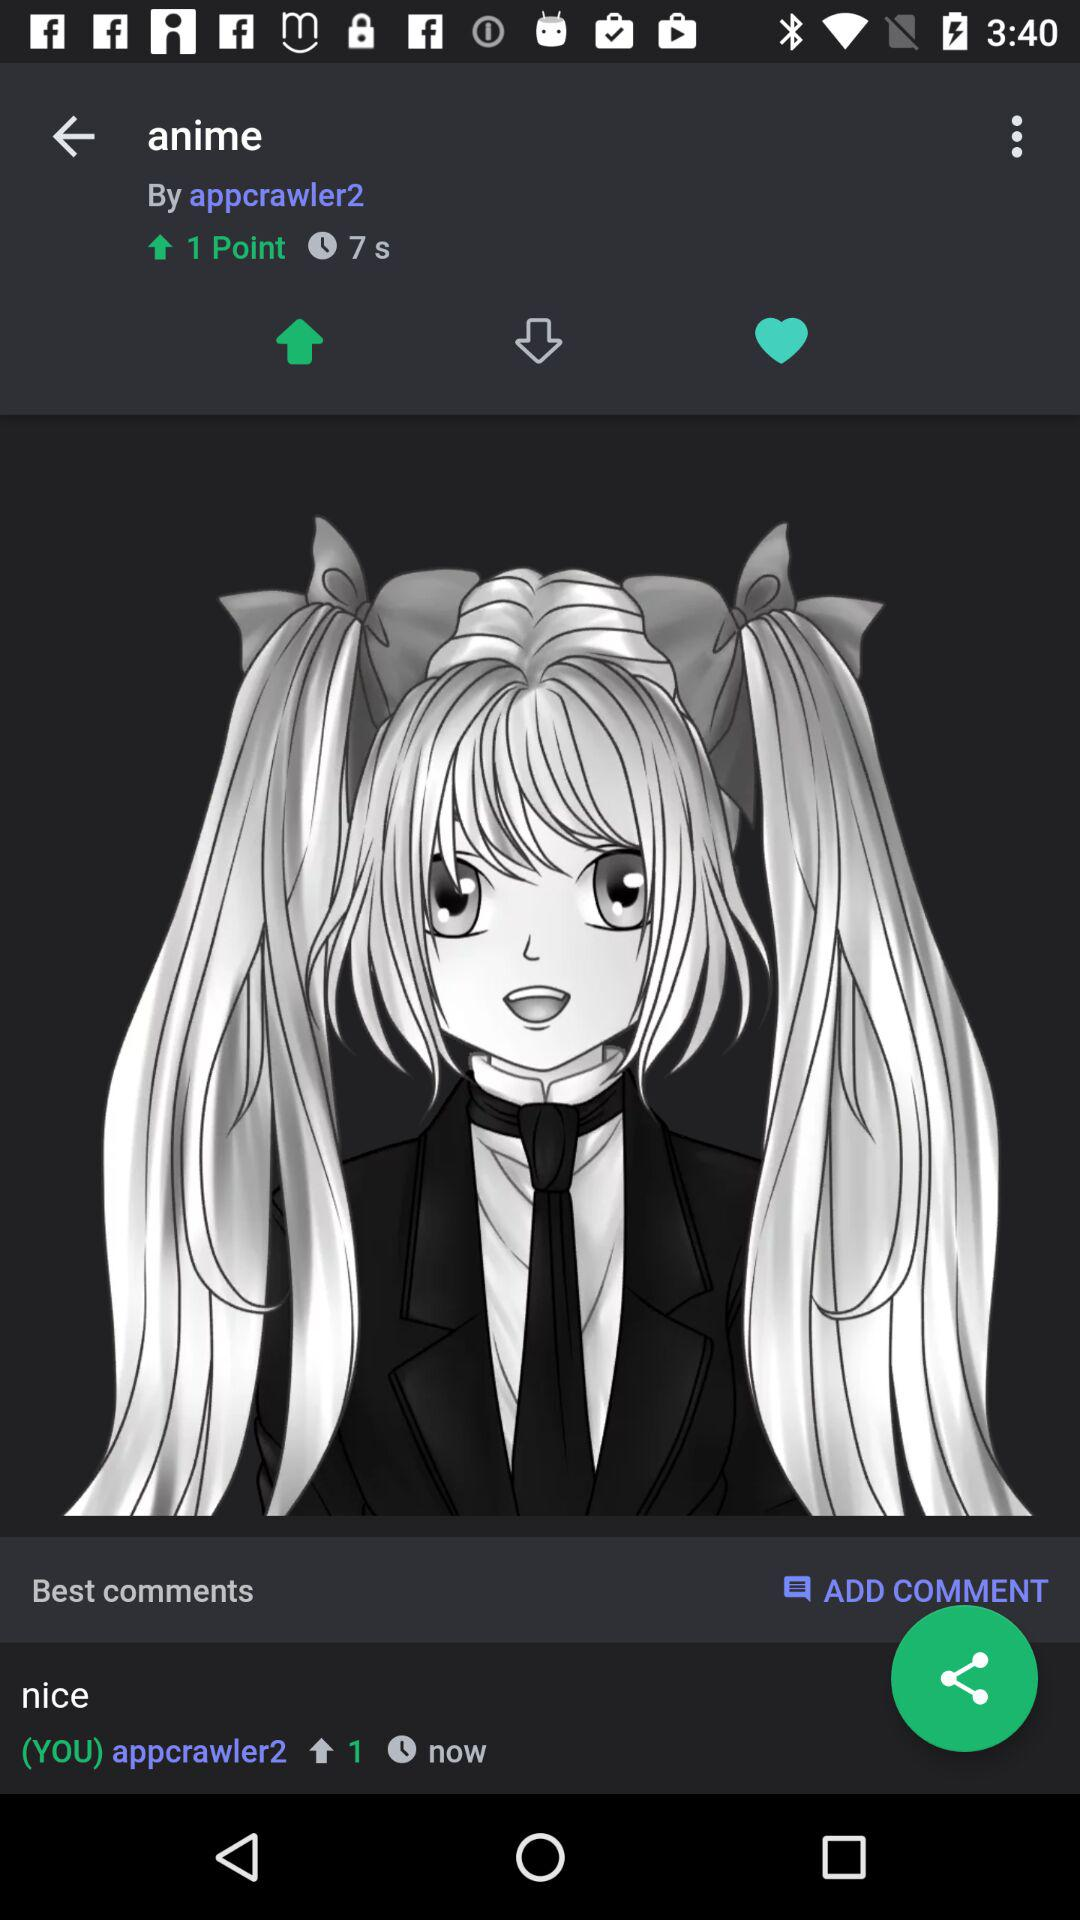How many seconds ago was the top comment made?
Answer the question using a single word or phrase. 7 